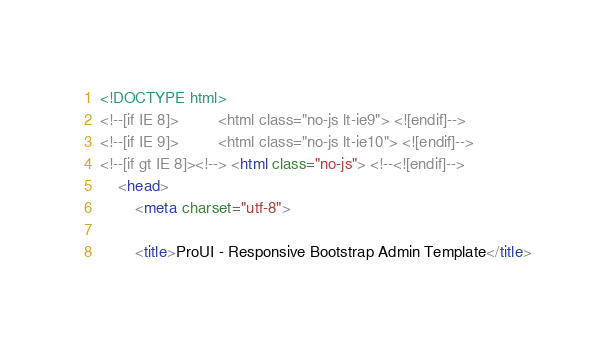<code> <loc_0><loc_0><loc_500><loc_500><_HTML_><!DOCTYPE html>
<!--[if IE 8]>         <html class="no-js lt-ie9"> <![endif]-->
<!--[if IE 9]>         <html class="no-js lt-ie10"> <![endif]-->
<!--[if gt IE 8]><!--> <html class="no-js"> <!--<![endif]-->
    <head>
        <meta charset="utf-8">

        <title>ProUI - Responsive Bootstrap Admin Template</title>
</code> 